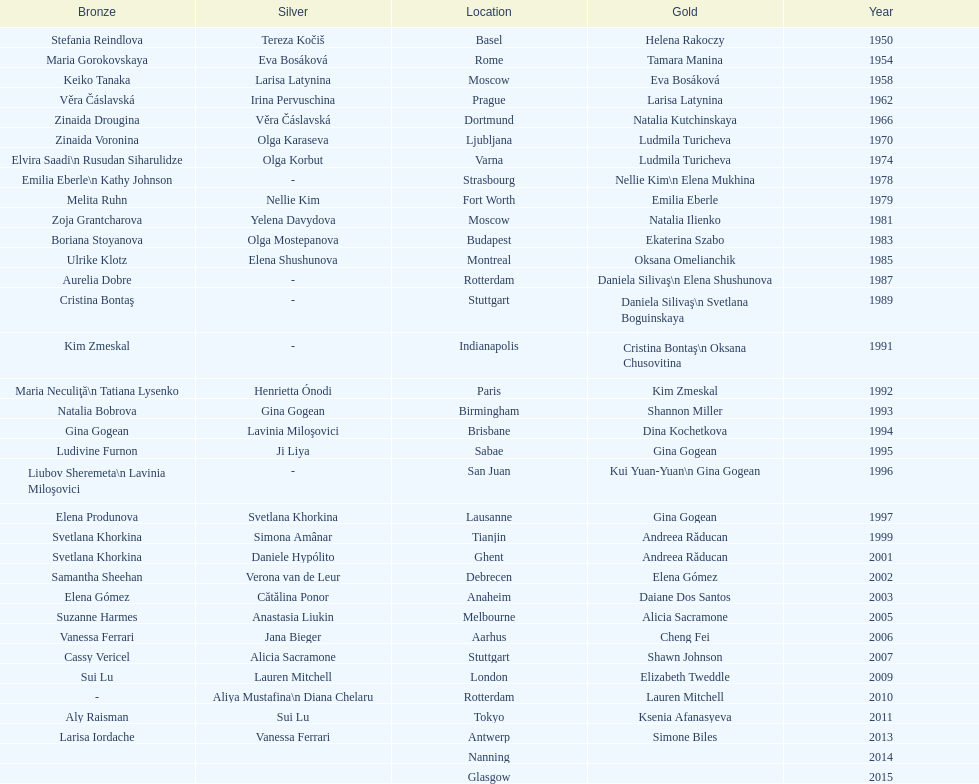How many instances was the location in the united states? 3. 